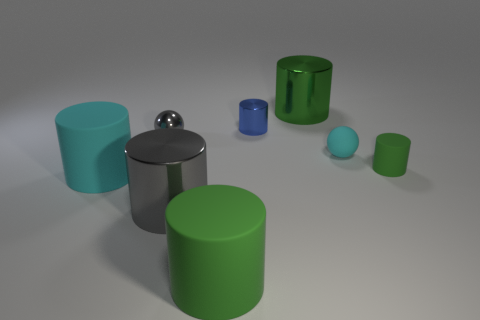How many objects are either large objects behind the large cyan rubber object or small metallic balls?
Provide a succinct answer. 2. What is the color of the ball that is the same material as the large gray thing?
Your response must be concise. Gray. Is there a brown cylinder of the same size as the cyan cylinder?
Provide a succinct answer. No. Does the big matte cylinder left of the large gray metal object have the same color as the matte sphere?
Give a very brief answer. Yes. What color is the rubber cylinder that is behind the big green matte cylinder and on the left side of the small blue cylinder?
Provide a succinct answer. Cyan. What shape is the blue thing that is the same size as the cyan matte sphere?
Offer a terse response. Cylinder. Is there a rubber thing of the same shape as the green metallic object?
Make the answer very short. Yes. Do the cylinder right of the cyan sphere and the small cyan matte object have the same size?
Ensure brevity in your answer.  Yes. What size is the green cylinder that is both to the left of the tiny green matte object and behind the cyan cylinder?
Provide a short and direct response. Large. How many other things are there of the same material as the gray cylinder?
Provide a succinct answer. 3. 